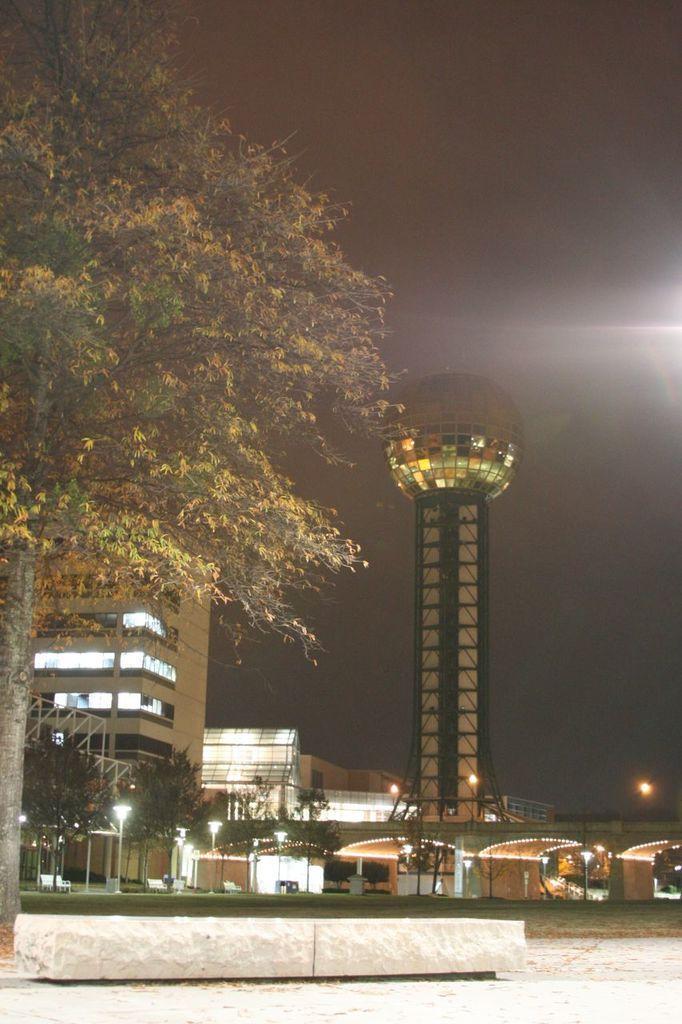Please provide a concise description of this image. In this image I can see few buildings, windows, trees, light-poles, tower and the sky. 